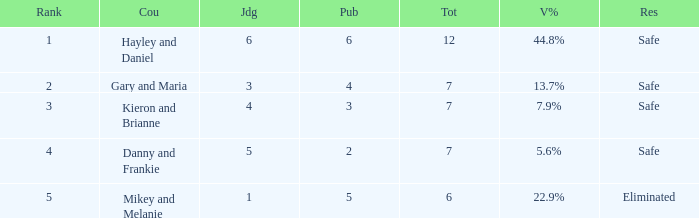How many judges were there for the eliminated couple?  1.0. 